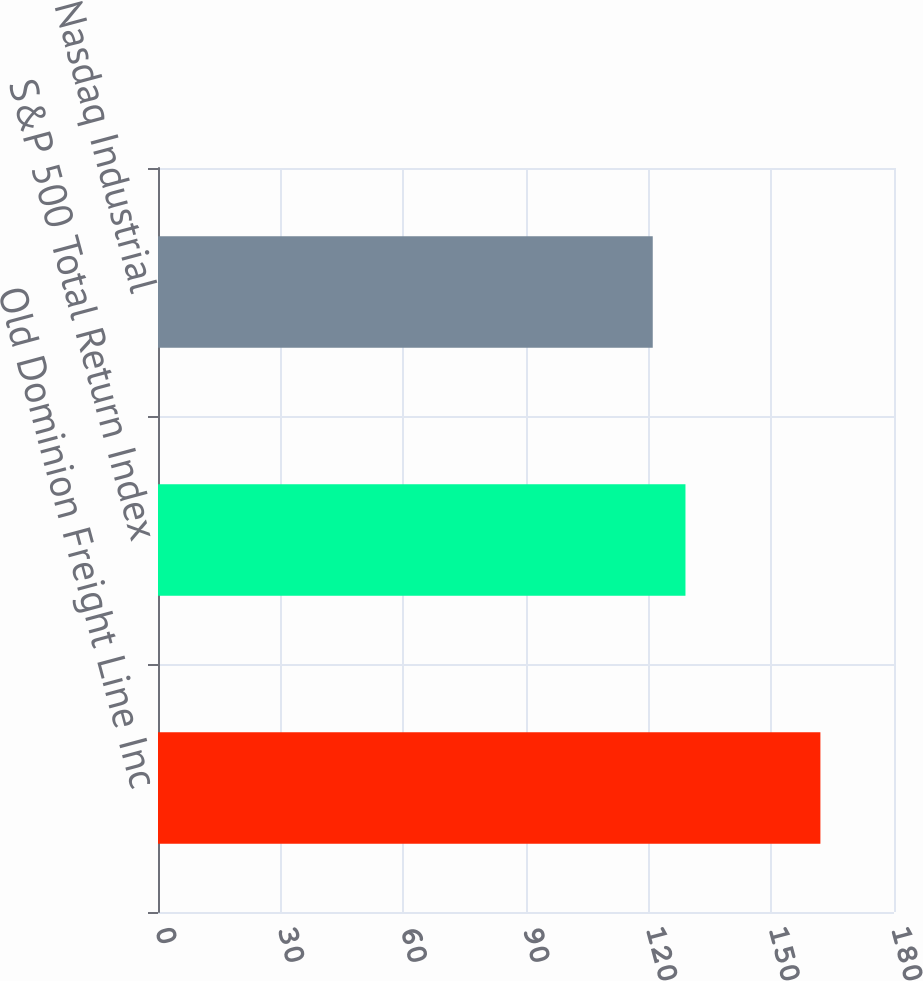<chart> <loc_0><loc_0><loc_500><loc_500><bar_chart><fcel>Old Dominion Freight Line Inc<fcel>S&P 500 Total Return Index<fcel>Nasdaq Industrial<nl><fcel>162<fcel>129<fcel>121<nl></chart> 